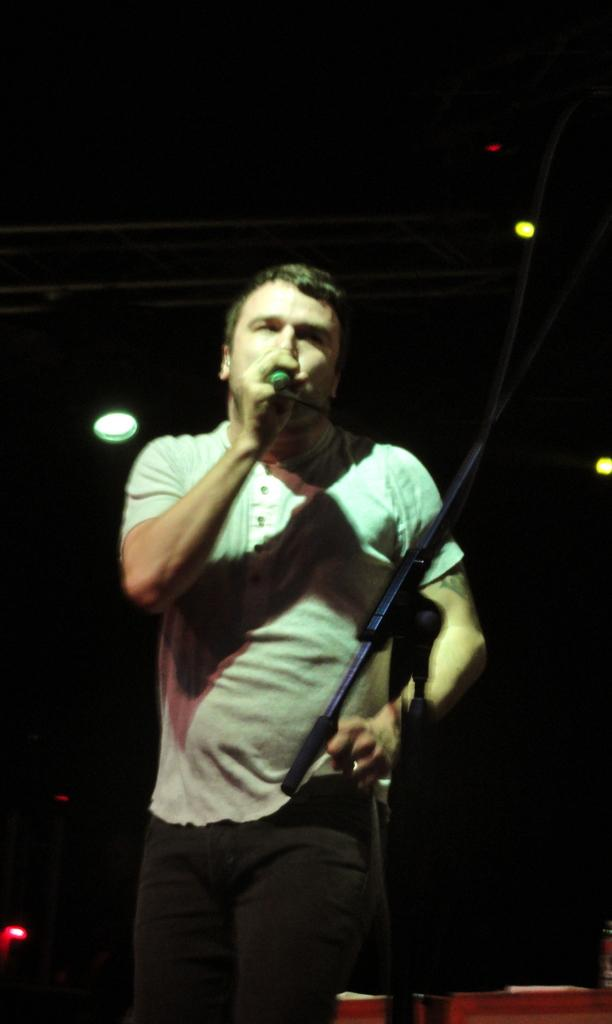What is the man in the image doing? The man is singing on a microphone in the image. What is the man holding while singing? The man is holding a microphone in the image. What is supporting the microphone when the man is not holding it? There is a microphone stand in the image. What can be seen illuminating the scene in the image? Show lights are visible in the image. How would you describe the lighting conditions in the background of the image? The background of the image appears dark. Where is the kitten playing with the lift in the image? There is no kitten or lift present in the image. What type of tiger can be seen performing on stage with the man? There is no tiger present in the image; the man is singing alone on stage. 